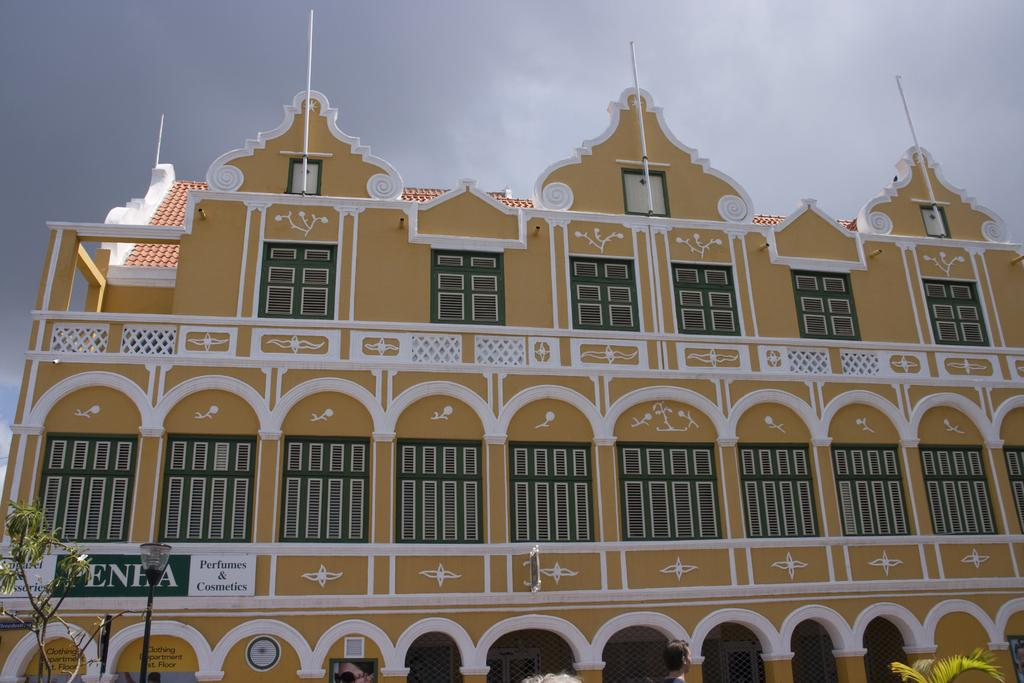What architectural features can be seen in the image? There are windows, a building, and pillars visible in the image. What is the source of light in the image? There is light visible in the image. What type of vegetation is present in the image? There is a tree in the image. What can be seen in the sky in the image? The sky is visible in the image, and clouds are present. What type of weather is depicted in the image? The provided facts do not mention any specific weather conditions, so it cannot be determined from the image. Can you tell me the name of the father in the image? There is no person or father mentioned in the image, so it cannot be determined. 